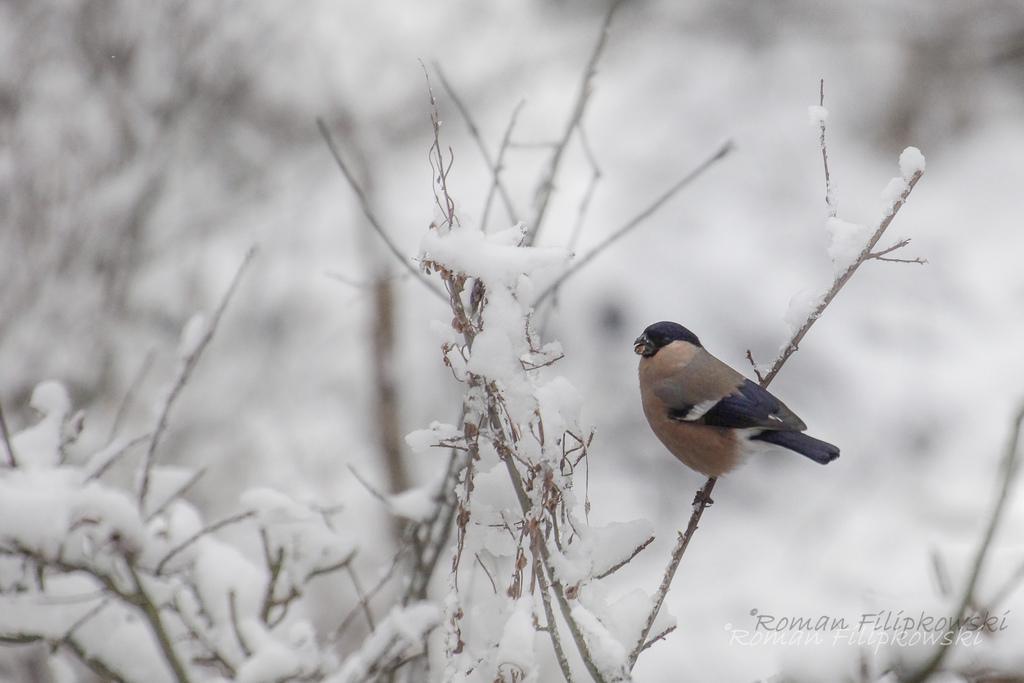Can you describe this image briefly? In this image I can see the bird in brown and black color and I can also see few plants covered with snow and I can see the white color background. 